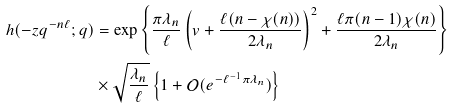<formula> <loc_0><loc_0><loc_500><loc_500>h ( - z q ^ { - n \ell } ; q ) & = \exp \left \{ \frac { \pi \lambda _ { n } } { \ell } \left ( v + \frac { \ell ( n - \chi ( n ) ) } { 2 \lambda _ { n } } \right ) ^ { 2 } + \frac { \ell \pi ( n - 1 ) \chi ( n ) } { 2 \lambda _ { n } } \right \} \\ & \times \sqrt { \frac { \lambda _ { n } } { \ell } } \left \{ 1 + \mathcal { O } ( e ^ { - \ell ^ { - 1 } \pi \lambda _ { n } } ) \right \}</formula> 